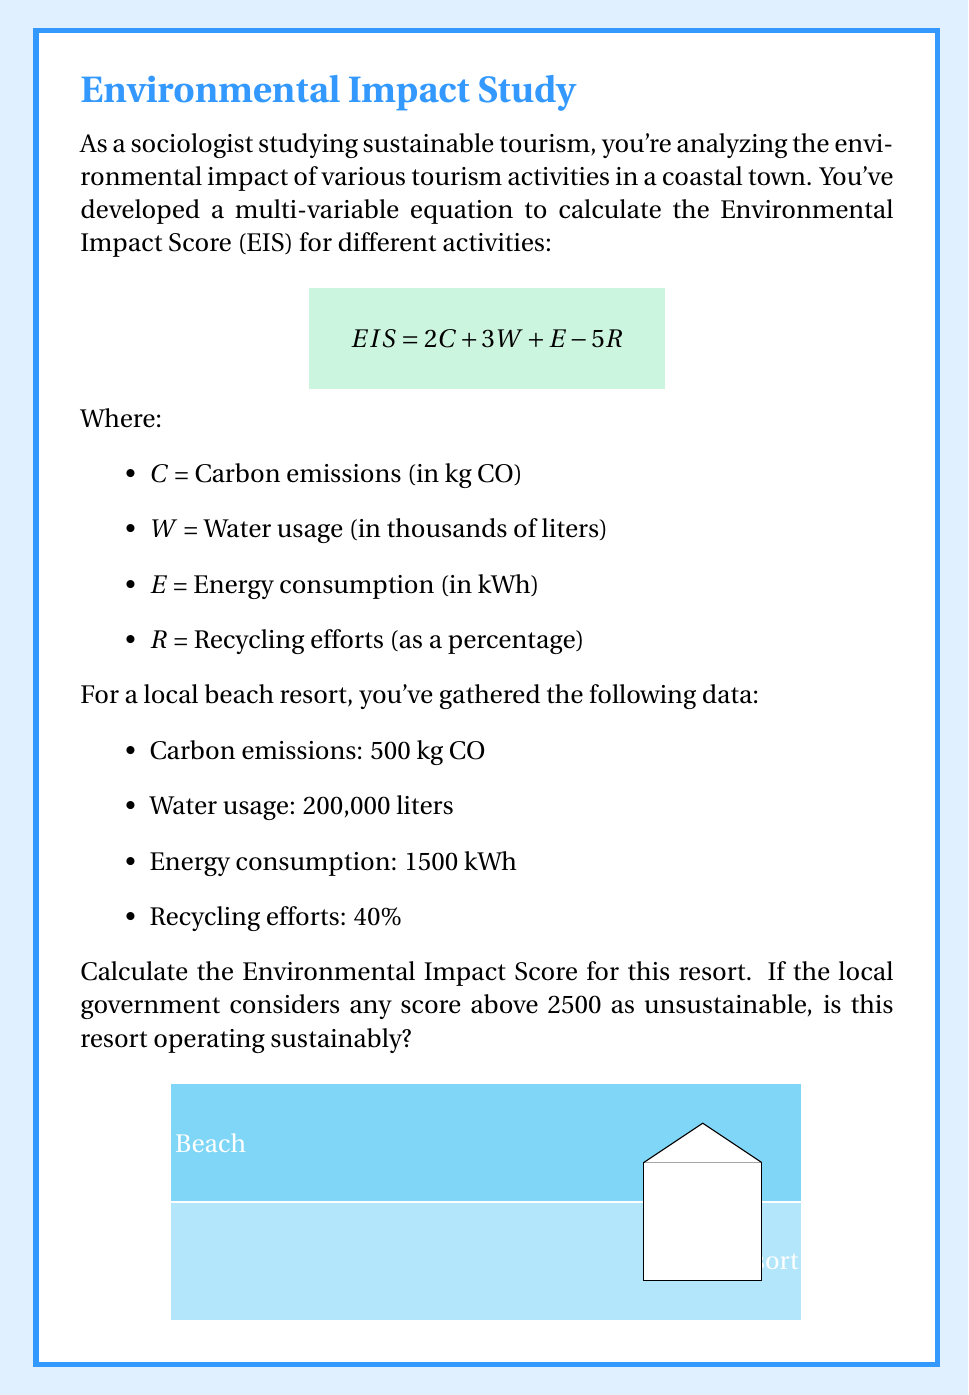Provide a solution to this math problem. Let's approach this problem step-by-step using the given equation:

$$ EIS = 2C + 3W + E - 5R $$

1) First, let's substitute the given values:
   C = 500 kg CO₂
   W = 200 thousand liters = 200
   E = 1500 kWh
   R = 40%

2) Now, let's plug these values into our equation:

   $$ EIS = 2(500) + 3(200) + 1500 - 5(40) $$

3) Let's calculate each term:
   - 2C = 2 * 500 = 1000
   - 3W = 3 * 200 = 600
   - E = 1500
   - 5R = 5 * 40 = 200

4) Now we can simplify:

   $$ EIS = 1000 + 600 + 1500 - 200 $$

5) Adding and subtracting:

   $$ EIS = 2900 $$

6) To determine if the resort is operating sustainably, we compare this score to the threshold of 2500 set by the local government.

   2900 > 2500

Therefore, the resort's Environmental Impact Score is above the sustainability threshold.
Answer: EIS = 2900; Not sustainable 